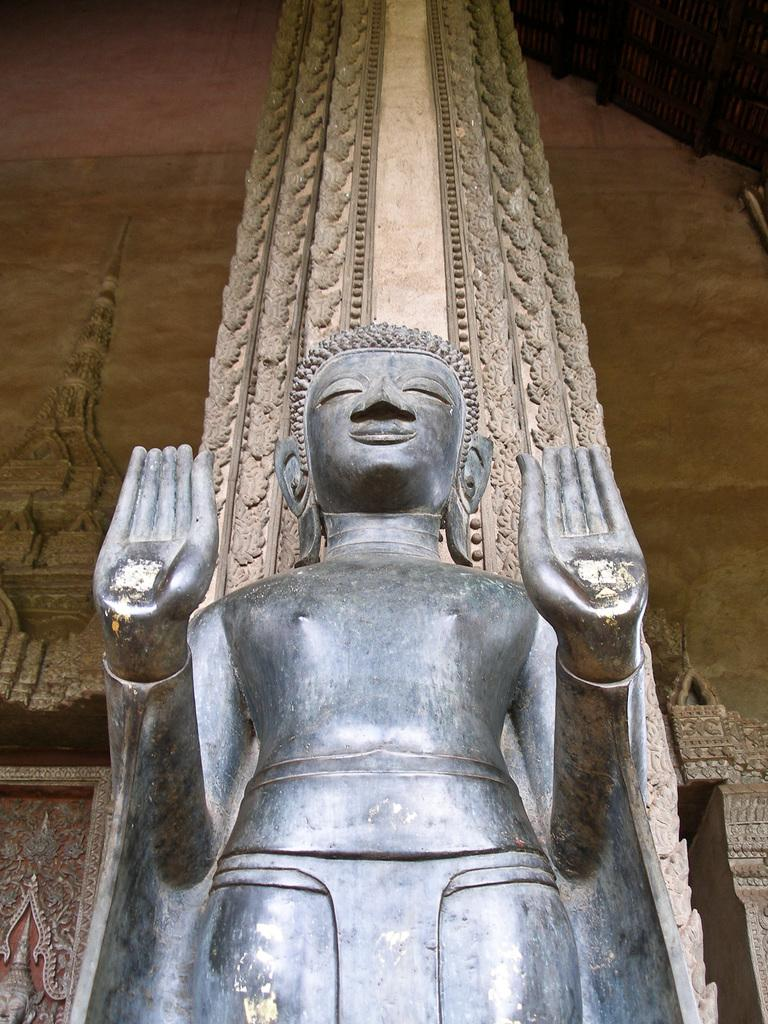What is the main subject in the image? There is a statue in the image. Can you describe the background of the image? There is a tower visible in the background of the image. What type of crack can be seen on the statue in the image? There is no crack visible on the statue in the image. What is the slope of the railway in the image? There is no railway present in the image. 